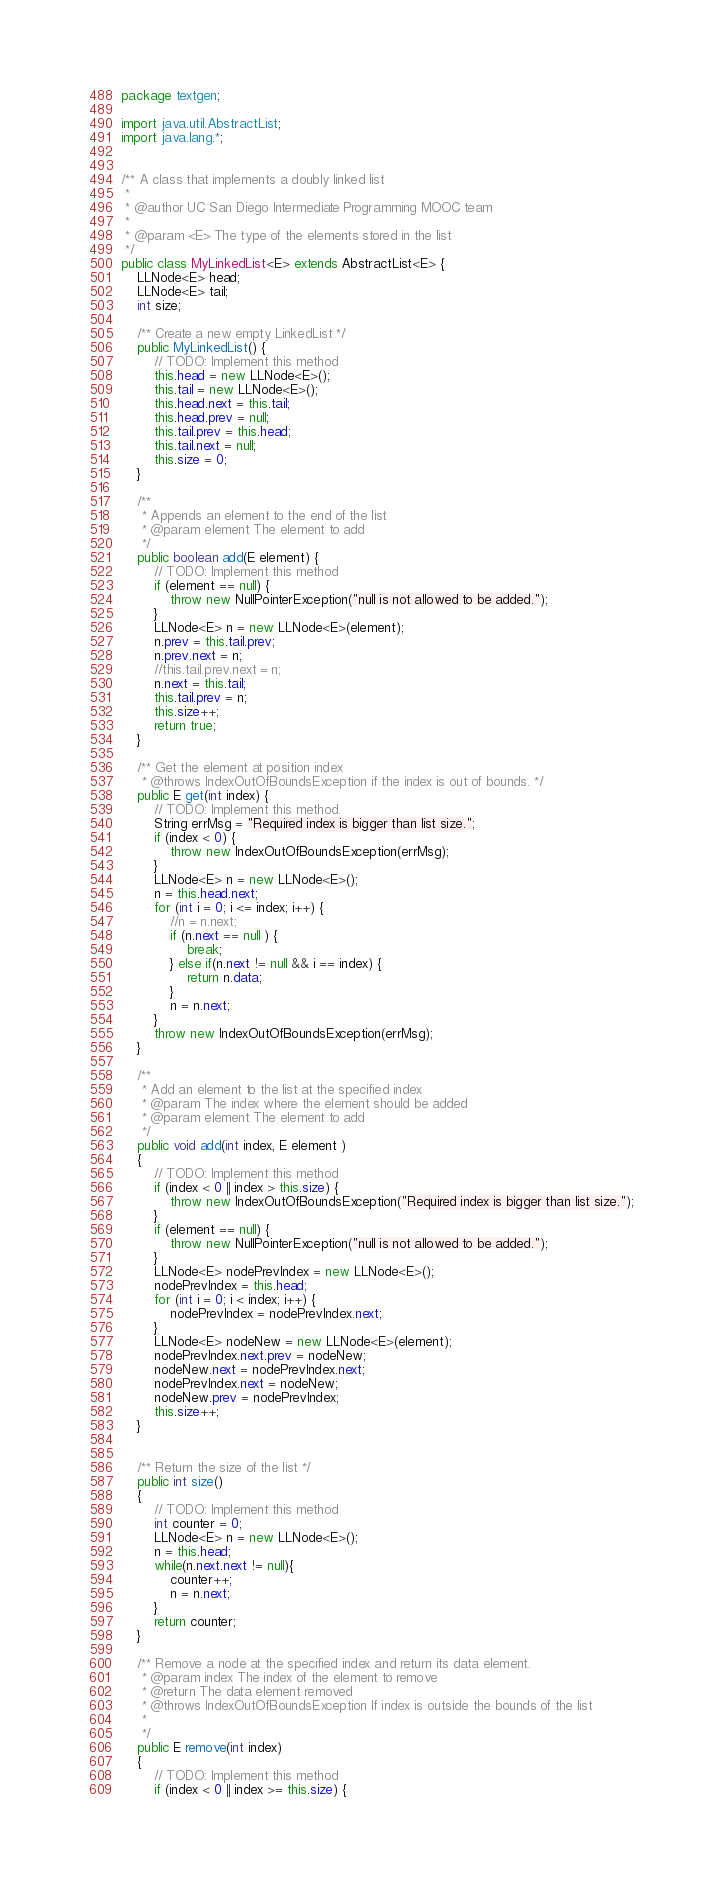Convert code to text. <code><loc_0><loc_0><loc_500><loc_500><_Java_>package textgen;

import java.util.AbstractList;
import java.lang.*;


/** A class that implements a doubly linked list
 * 
 * @author UC San Diego Intermediate Programming MOOC team
 *
 * @param <E> The type of the elements stored in the list
 */
public class MyLinkedList<E> extends AbstractList<E> {
	LLNode<E> head;
	LLNode<E> tail;
	int size;

	/** Create a new empty LinkedList */
	public MyLinkedList() {
		// TODO: Implement this method
		this.head = new LLNode<E>();
		this.tail = new LLNode<E>();
		this.head.next = this.tail;
		this.head.prev = null;
		this.tail.prev = this.head;
		this.tail.next = null;
		this.size = 0;
	}

	/**
	 * Appends an element to the end of the list
	 * @param element The element to add
	 */
	public boolean add(E element) {
		// TODO: Implement this method
		if (element == null) {
			throw new NullPointerException("null is not allowed to be added.");
		}
		LLNode<E> n = new LLNode<E>(element);
		n.prev = this.tail.prev;
		n.prev.next = n;
		//this.tail.prev.next = n;
		n.next = this.tail;
		this.tail.prev = n;
		this.size++;
		return true;
	}

	/** Get the element at position index 
	 * @throws IndexOutOfBoundsException if the index is out of bounds. */
	public E get(int index) {
		// TODO: Implement this method.
		String errMsg = "Required index is bigger than list size.";
		if (index < 0) {
			throw new IndexOutOfBoundsException(errMsg);
		}
		LLNode<E> n = new LLNode<E>();
		n = this.head.next;
		for (int i = 0; i <= index; i++) {
			//n = n.next;
			if (n.next == null ) {
				break;
			} else if(n.next != null && i == index) {
				return n.data;
			} 
			n = n.next;
		}
		throw new IndexOutOfBoundsException(errMsg);
	}

	/**
	 * Add an element to the list at the specified index
	 * @param The index where the element should be added
	 * @param element The element to add
	 */
	public void add(int index, E element ) 
	{
		// TODO: Implement this method
		if (index < 0 || index > this.size) {
			throw new IndexOutOfBoundsException("Required index is bigger than list size.");
		}
		if (element == null) {
			throw new NullPointerException("null is not allowed to be added.");
		}
		LLNode<E> nodePrevIndex = new LLNode<E>();
		nodePrevIndex = this.head;
		for (int i = 0; i < index; i++) {
			nodePrevIndex = nodePrevIndex.next;
		}
		LLNode<E> nodeNew = new LLNode<E>(element);
		nodePrevIndex.next.prev = nodeNew;
		nodeNew.next = nodePrevIndex.next;
		nodePrevIndex.next = nodeNew;
		nodeNew.prev = nodePrevIndex;
		this.size++;
	}


	/** Return the size of the list */
	public int size() 
	{
		// TODO: Implement this method
		int counter = 0;
		LLNode<E> n = new LLNode<E>();
		n = this.head;
		while(n.next.next != null){
			counter++;
			n = n.next;
		}
		return counter;
	}

	/** Remove a node at the specified index and return its data element.
	 * @param index The index of the element to remove
	 * @return The data element removed
	 * @throws IndexOutOfBoundsException If index is outside the bounds of the list
	 * 
	 */
	public E remove(int index) 
	{
		// TODO: Implement this method
		if (index < 0 || index >= this.size) {</code> 